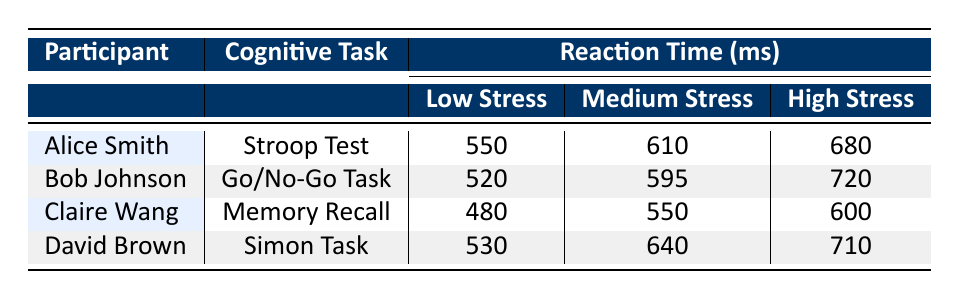What is the reaction time of Alice Smith in the Stroop Test at medium stress? The table provides the specific reaction time values for each participant under different stress levels and tasks. For Alice Smith, under the cognitive task of the Stroop Test and at a medium stress level, the reaction time is listed as 610 ms.
Answer: 610 ms Which participant had the lowest reaction time at low stress? To identify the participant with the lowest reaction time under low stress, we need to compare the values in that category. The low stress reaction times are: Alice Smith (550 ms), Bob Johnson (520 ms), Claire Wang (480 ms), and David Brown (530 ms). The lowest value is 480 ms from Claire Wang.
Answer: Claire Wang What is the difference in reaction time for Bob Johnson between low and high stress? For Bob Johnson, the reaction times at low and high stress are 520 ms and 720 ms, respectively. To find the difference, we subtract the low stress time from the high stress time: 720 ms - 520 ms = 200 ms.
Answer: 200 ms Is it true that all participants have increased reaction times from low to high stress? We can examine the reaction times for all participants under low and high stress to determine this. Alice Smith: 550 ms to 680 ms; Bob Johnson: 520 ms to 720 ms; Claire Wang: 480 ms to 600 ms; David Brown: 530 ms to 710 ms. All participants show increased reaction times, hence the statement is true.
Answer: Yes What is the average reaction time for David Brown across all stress levels? To calculate the average for David Brown, we first sum his reaction times at all stress levels: 530 ms (low) + 640 ms (medium) + 710 ms (high) = 1880 ms. Dividing this sum by the number of stress levels, which is 3, gives 1880 ms / 3 = 626.67 ms.
Answer: 626.67 ms Under which task did Claire Wang perform best at low stress? We compare reaction times across tasks for Claire Wang under low stress. The relevant values are: Stroop Test (not applicable), Go/No-Go Task (not applicable), Memory Recall (480 ms), and Simon Task (not applicable). Only Memory Recall applies here, and it shows that she had the lowest reaction time compared to the other tasks.
Answer: Memory Recall What is the total increase in reaction time from low to high stress for all tasks combined? To find the total increase, we calculate the difference for each participant from low to high stress and then sum these differences. The differences are: Alice Smith (680 ms - 550 ms = 130 ms), Bob Johnson (720 ms - 520 ms = 200 ms), Claire Wang (600 ms - 480 ms = 120 ms), and David Brown (710 ms - 530 ms = 180 ms). Summing these increases gives 130 + 200 + 120 + 180 = 630 ms.
Answer: 630 ms 